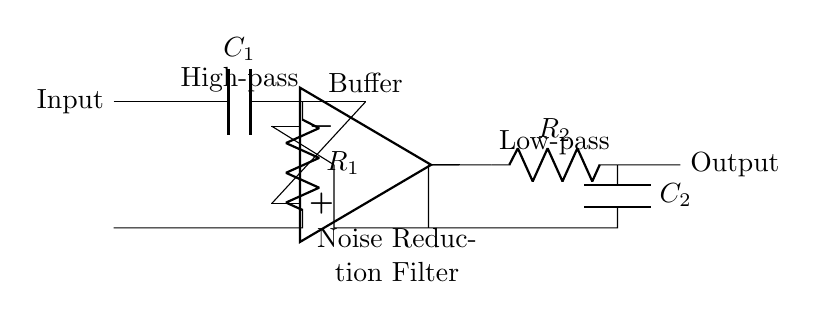What type of filter is represented in this circuit? The circuit contains a combination of a high-pass and a low-pass filter, specifically designed to reduce noise. The high-pass filter allows frequencies above a certain cutoff to pass while attenuating lower frequencies, and the low-pass filter does the opposite.
Answer: Noise reduction filter What component is used for high-pass filtering? The high-pass filter is created using a capacitor and a resistor. The capacitor blocks low frequencies, allowing high frequencies to be processed by the subsequent stages of the circuit.
Answer: Capacitor What is the function of the op-amp in this circuit? The operational amplifier (op-amp) acts as a buffer to isolate the high-pass filter from the low-pass filter. It provides the necessary gain while maintaining signal integrity and impedance matching between stages.
Answer: Buffer Identify the resistor associated with the low-pass filter. The low-pass filter includes resistor R2, which, in conjunction with capacitor C2, defines the cutoff frequency below which signals are attenuated.
Answer: R2 What is the output of this circuit? The output of the circuit is taken from the final stage after the low-pass filter, which processes the input signal to reduce unwanted noise.
Answer: Output Which component determines the cutoff frequency for the high-pass filter? In the high-pass filter section, the cutoff frequency is determined by the combination of capacitor C1 and resistor R1 according to the formula for the cutoff frequency in RC circuits.
Answer: C1 and R1 